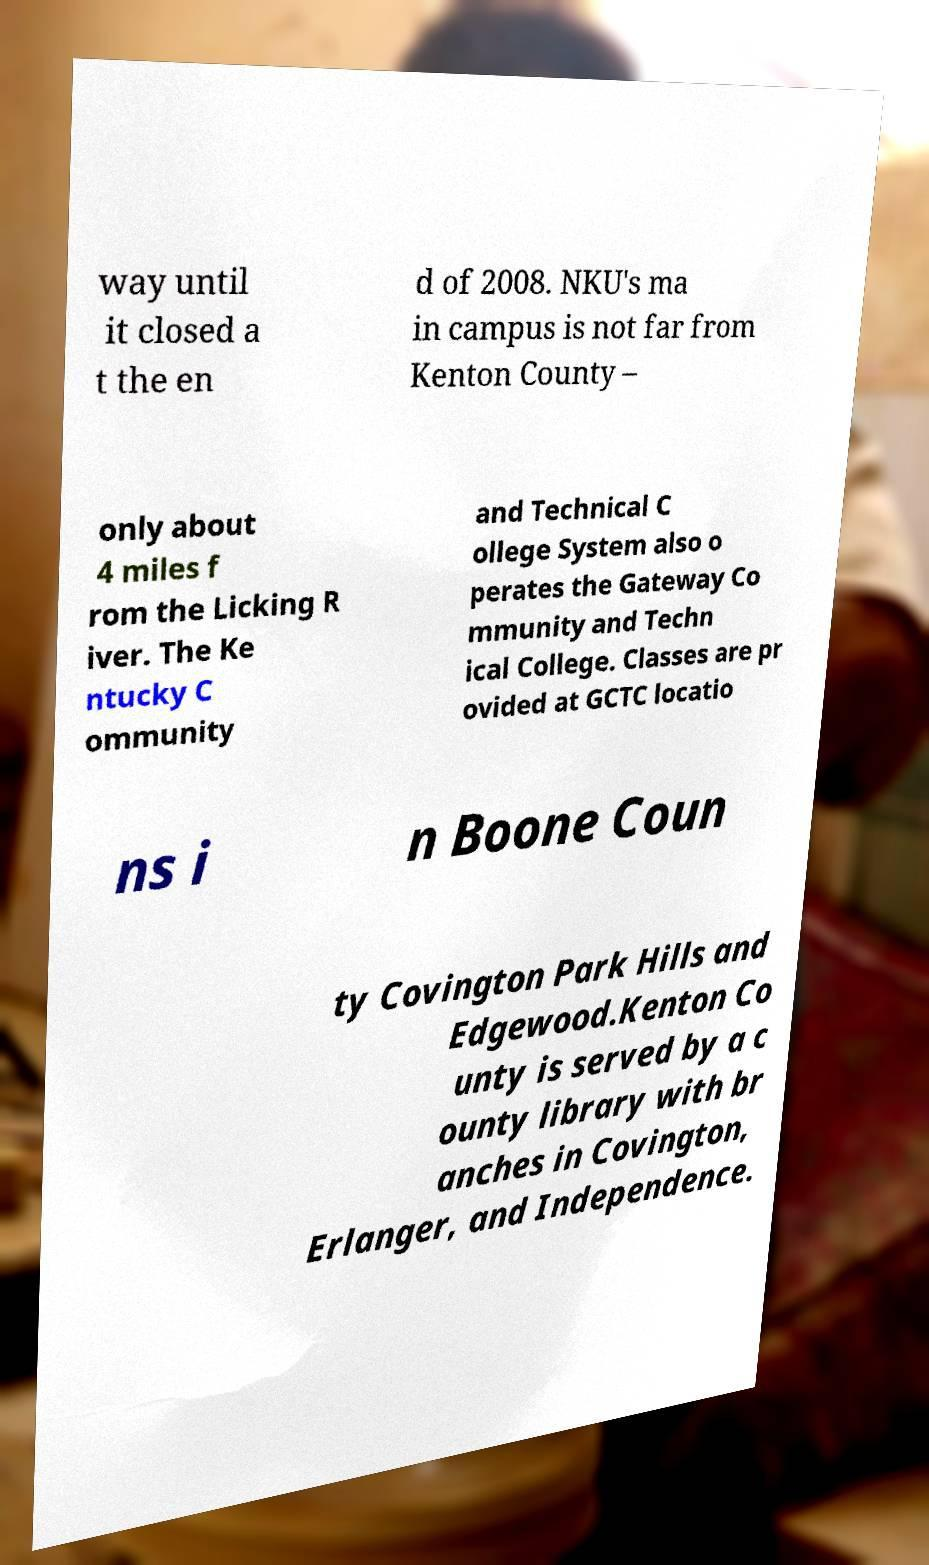Could you extract and type out the text from this image? way until it closed a t the en d of 2008. NKU's ma in campus is not far from Kenton County – only about 4 miles f rom the Licking R iver. The Ke ntucky C ommunity and Technical C ollege System also o perates the Gateway Co mmunity and Techn ical College. Classes are pr ovided at GCTC locatio ns i n Boone Coun ty Covington Park Hills and Edgewood.Kenton Co unty is served by a c ounty library with br anches in Covington, Erlanger, and Independence. 